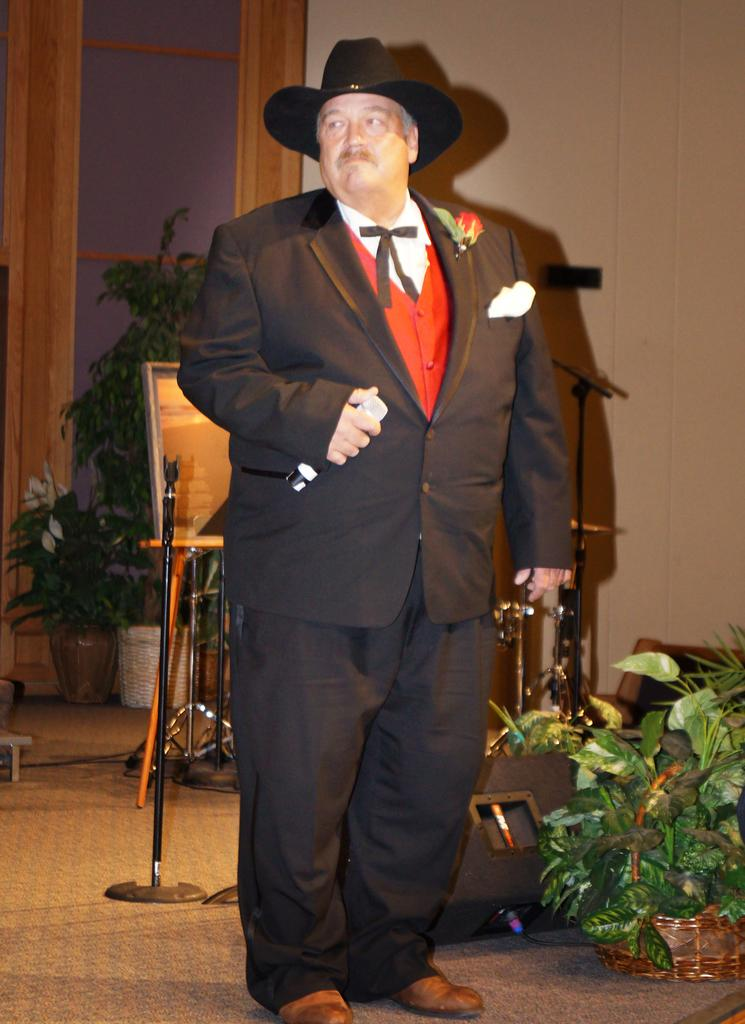What is the main subject of the image? The main subject of the image is a man. What is the man wearing? The man is wearing a black blazer and a hat. What is the man holding in the image? The man is holding a microphone. What can be seen in the background of the image? There is a wall and a glass window in the background of the image. What is located on the right side of the man? There are flower pots on the right side of the man. How many stories tall is the van in the image? There is no van present in the image, so it is not possible to determine its height or number of stories. 